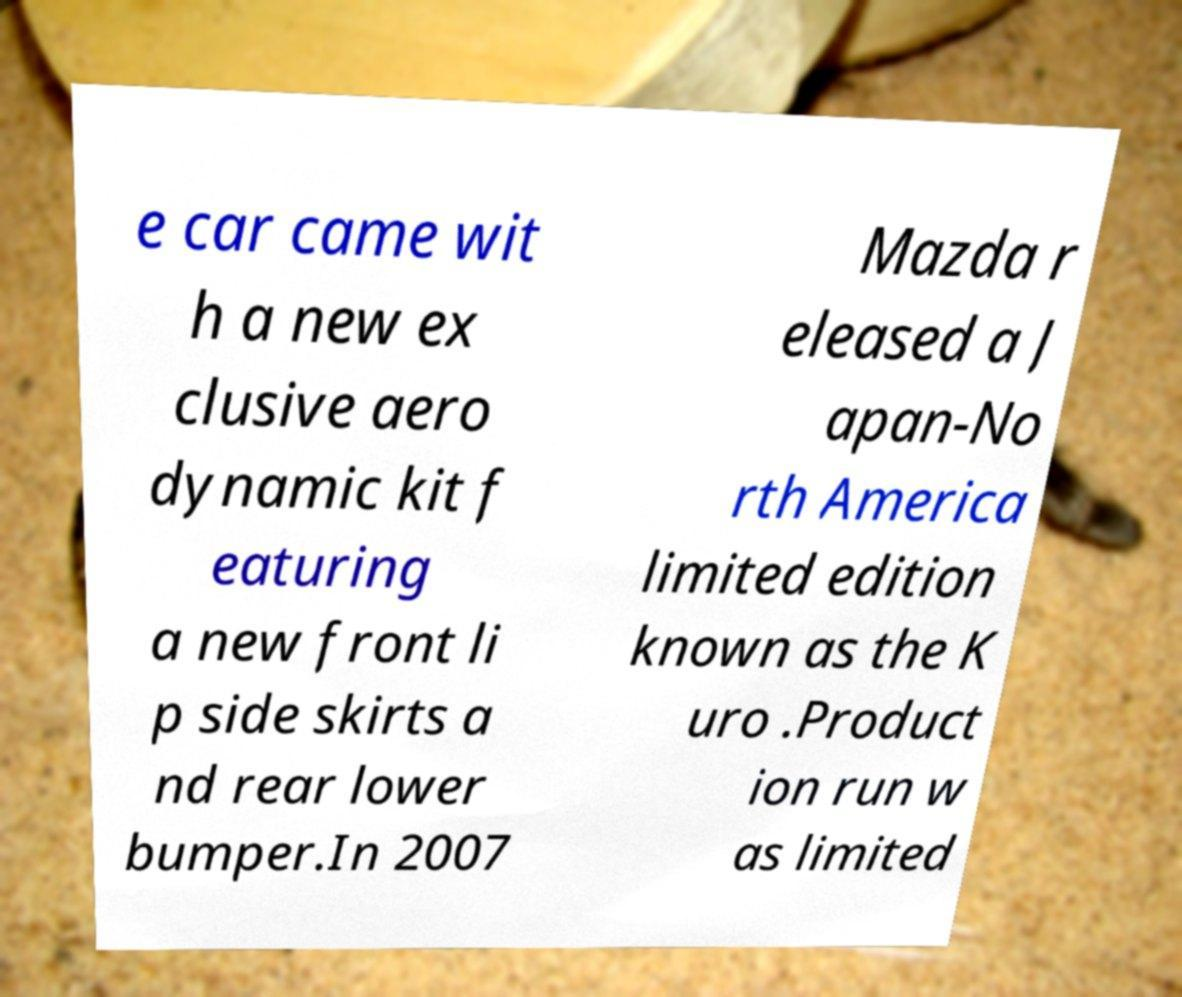I need the written content from this picture converted into text. Can you do that? e car came wit h a new ex clusive aero dynamic kit f eaturing a new front li p side skirts a nd rear lower bumper.In 2007 Mazda r eleased a J apan-No rth America limited edition known as the K uro .Product ion run w as limited 